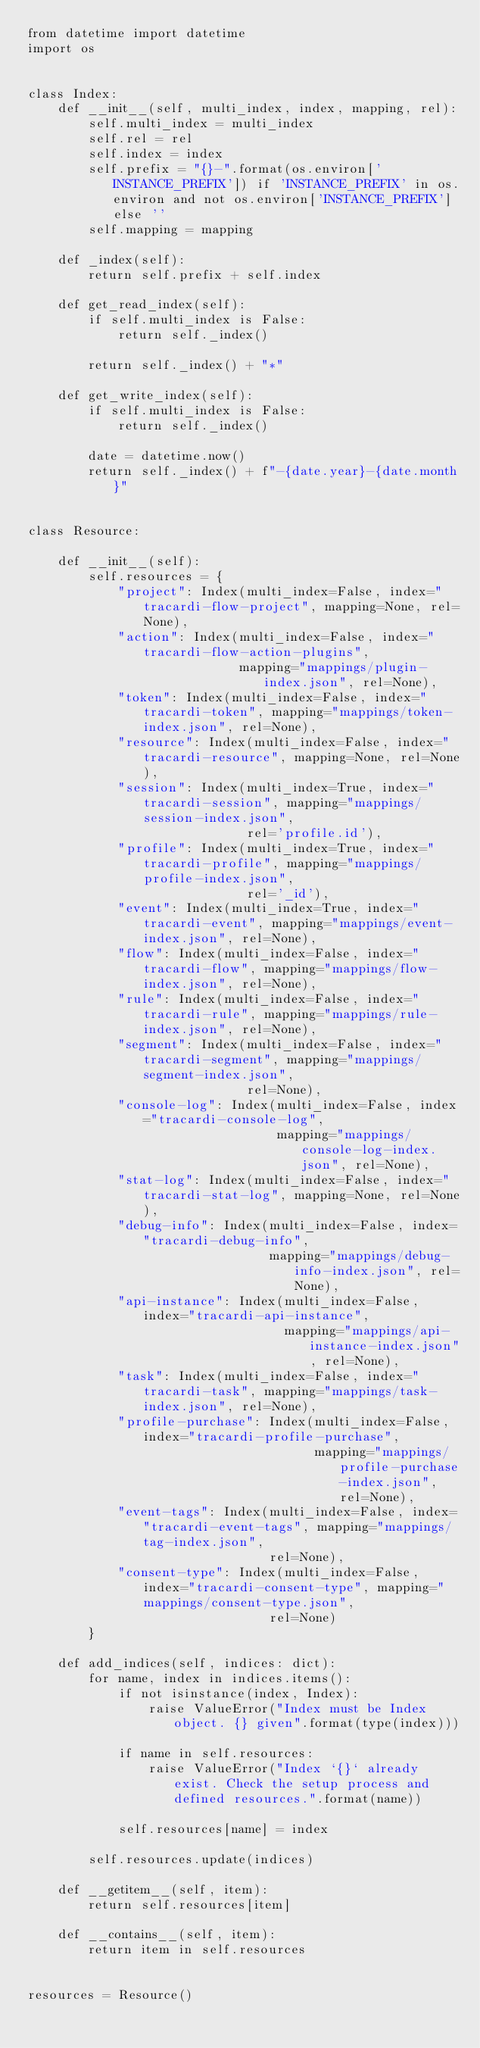<code> <loc_0><loc_0><loc_500><loc_500><_Python_>from datetime import datetime
import os


class Index:
    def __init__(self, multi_index, index, mapping, rel):
        self.multi_index = multi_index
        self.rel = rel
        self.index = index
        self.prefix = "{}-".format(os.environ['INSTANCE_PREFIX']) if 'INSTANCE_PREFIX' in os.environ and not os.environ['INSTANCE_PREFIX'] else ''
        self.mapping = mapping

    def _index(self):
        return self.prefix + self.index

    def get_read_index(self):
        if self.multi_index is False:
            return self._index()

        return self._index() + "*"

    def get_write_index(self):
        if self.multi_index is False:
            return self._index()

        date = datetime.now()
        return self._index() + f"-{date.year}-{date.month}"


class Resource:

    def __init__(self):
        self.resources = {
            "project": Index(multi_index=False, index="tracardi-flow-project", mapping=None, rel=None),
            "action": Index(multi_index=False, index="tracardi-flow-action-plugins",
                            mapping="mappings/plugin-index.json", rel=None),
            "token": Index(multi_index=False, index="tracardi-token", mapping="mappings/token-index.json", rel=None),
            "resource": Index(multi_index=False, index="tracardi-resource", mapping=None, rel=None),
            "session": Index(multi_index=True, index="tracardi-session", mapping="mappings/session-index.json",
                             rel='profile.id'),
            "profile": Index(multi_index=True, index="tracardi-profile", mapping="mappings/profile-index.json",
                             rel='_id'),
            "event": Index(multi_index=True, index="tracardi-event", mapping="mappings/event-index.json", rel=None),
            "flow": Index(multi_index=False, index="tracardi-flow", mapping="mappings/flow-index.json", rel=None),
            "rule": Index(multi_index=False, index="tracardi-rule", mapping="mappings/rule-index.json", rel=None),
            "segment": Index(multi_index=False, index="tracardi-segment", mapping="mappings/segment-index.json",
                             rel=None),
            "console-log": Index(multi_index=False, index="tracardi-console-log",
                                 mapping="mappings/console-log-index.json", rel=None),
            "stat-log": Index(multi_index=False, index="tracardi-stat-log", mapping=None, rel=None),
            "debug-info": Index(multi_index=False, index="tracardi-debug-info",
                                mapping="mappings/debug-info-index.json", rel=None),
            "api-instance": Index(multi_index=False, index="tracardi-api-instance",
                                  mapping="mappings/api-instance-index.json", rel=None),
            "task": Index(multi_index=False, index="tracardi-task", mapping="mappings/task-index.json", rel=None),
            "profile-purchase": Index(multi_index=False, index="tracardi-profile-purchase",
                                      mapping="mappings/profile-purchase-index.json", rel=None),
            "event-tags": Index(multi_index=False, index="tracardi-event-tags", mapping="mappings/tag-index.json",
                                rel=None),
            "consent-type": Index(multi_index=False, index="tracardi-consent-type", mapping="mappings/consent-type.json",
                                rel=None)
        }

    def add_indices(self, indices: dict):
        for name, index in indices.items():
            if not isinstance(index, Index):
                raise ValueError("Index must be Index object. {} given".format(type(index)))

            if name in self.resources:
                raise ValueError("Index `{}` already exist. Check the setup process and defined resources.".format(name))

            self.resources[name] = index

        self.resources.update(indices)

    def __getitem__(self, item):
        return self.resources[item]

    def __contains__(self, item):
        return item in self.resources


resources = Resource()
</code> 